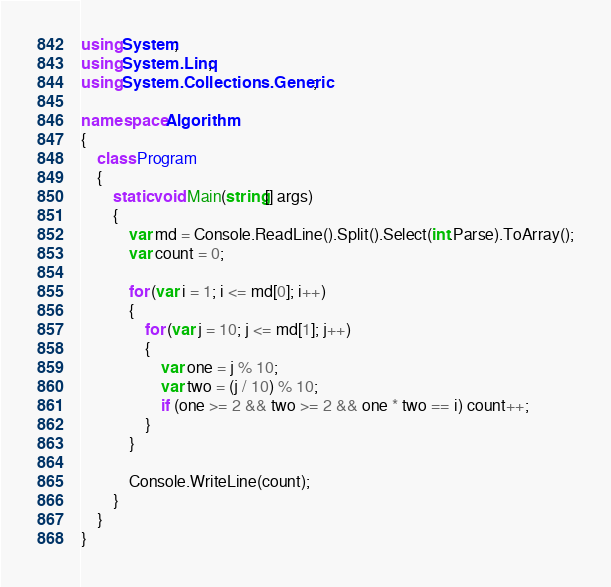Convert code to text. <code><loc_0><loc_0><loc_500><loc_500><_C#_>using System;
using System.Linq;
using System.Collections.Generic;

namespace Algorithm
{
    class Program
    {
        static void Main(string[] args)
        {
            var md = Console.ReadLine().Split().Select(int.Parse).ToArray();
            var count = 0;

            for (var i = 1; i <= md[0]; i++)
            {
                for (var j = 10; j <= md[1]; j++)
                {
                    var one = j % 10;
                    var two = (j / 10) % 10;
                    if (one >= 2 && two >= 2 && one * two == i) count++;
                }
            }

            Console.WriteLine(count);
        }
    }
}
</code> 